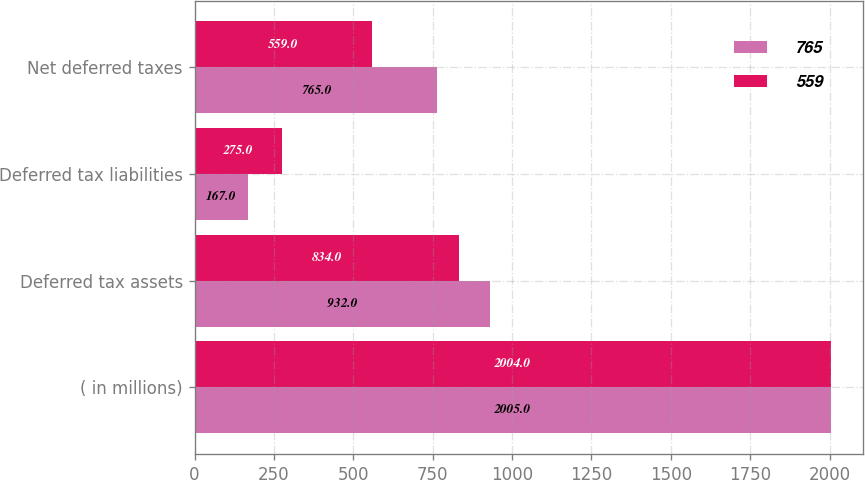Convert chart to OTSL. <chart><loc_0><loc_0><loc_500><loc_500><stacked_bar_chart><ecel><fcel>( in millions)<fcel>Deferred tax assets<fcel>Deferred tax liabilities<fcel>Net deferred taxes<nl><fcel>765<fcel>2005<fcel>932<fcel>167<fcel>765<nl><fcel>559<fcel>2004<fcel>834<fcel>275<fcel>559<nl></chart> 